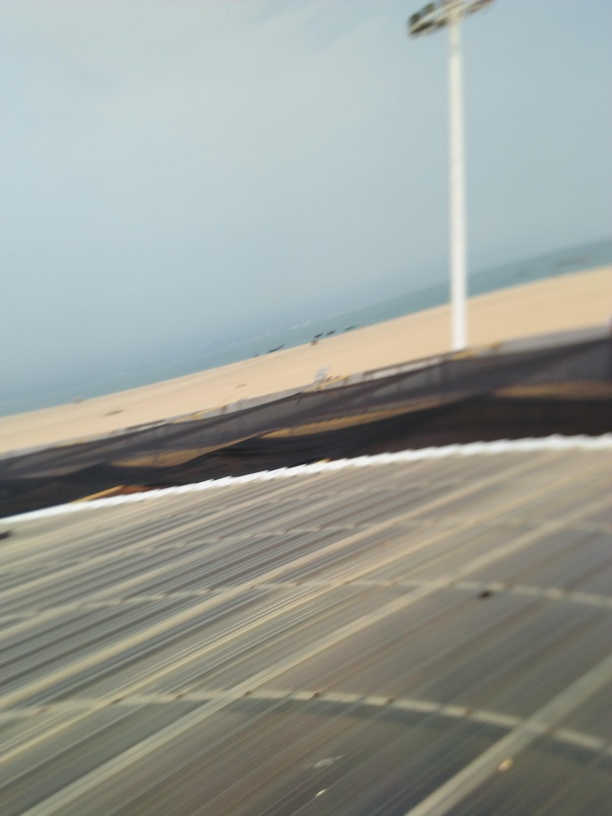What are some photography techniques that could be used to intentionally create an image like this with motion blur? To intentionally create motion blur in a photograph, a photographer might use a slow shutter speed while moving the camera during the exposure. This method, known as panning, can be employed to emphasize the speed of an object while the camera follows its movement. Additionally, zooming in or out while taking a photo can generate a dynamic blur effect that radiates outward or inward. Creative approaches also include shaking or rotating the camera, each method creating its own unique pattern of motion blur, which can be used artistically to convey motion or to add an abstract quality to the image. 